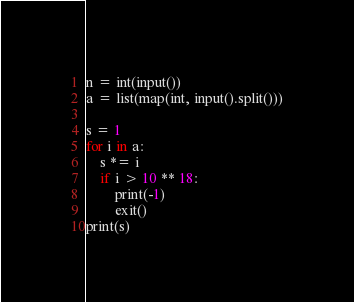<code> <loc_0><loc_0><loc_500><loc_500><_Python_>n = int(input())
a = list(map(int, input().split()))

s = 1
for i in a:
    s *= i
    if i > 10 ** 18:
        print(-1)
        exit()
print(s)</code> 